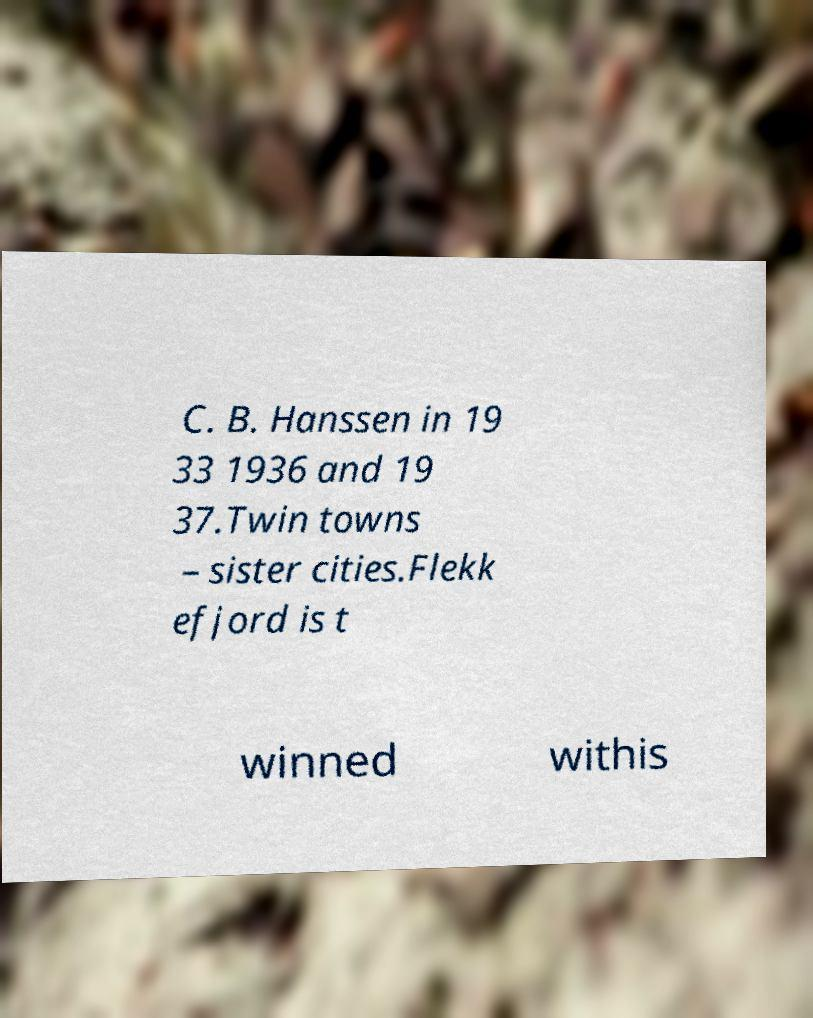Could you assist in decoding the text presented in this image and type it out clearly? C. B. Hanssen in 19 33 1936 and 19 37.Twin towns – sister cities.Flekk efjord is t winned withis 